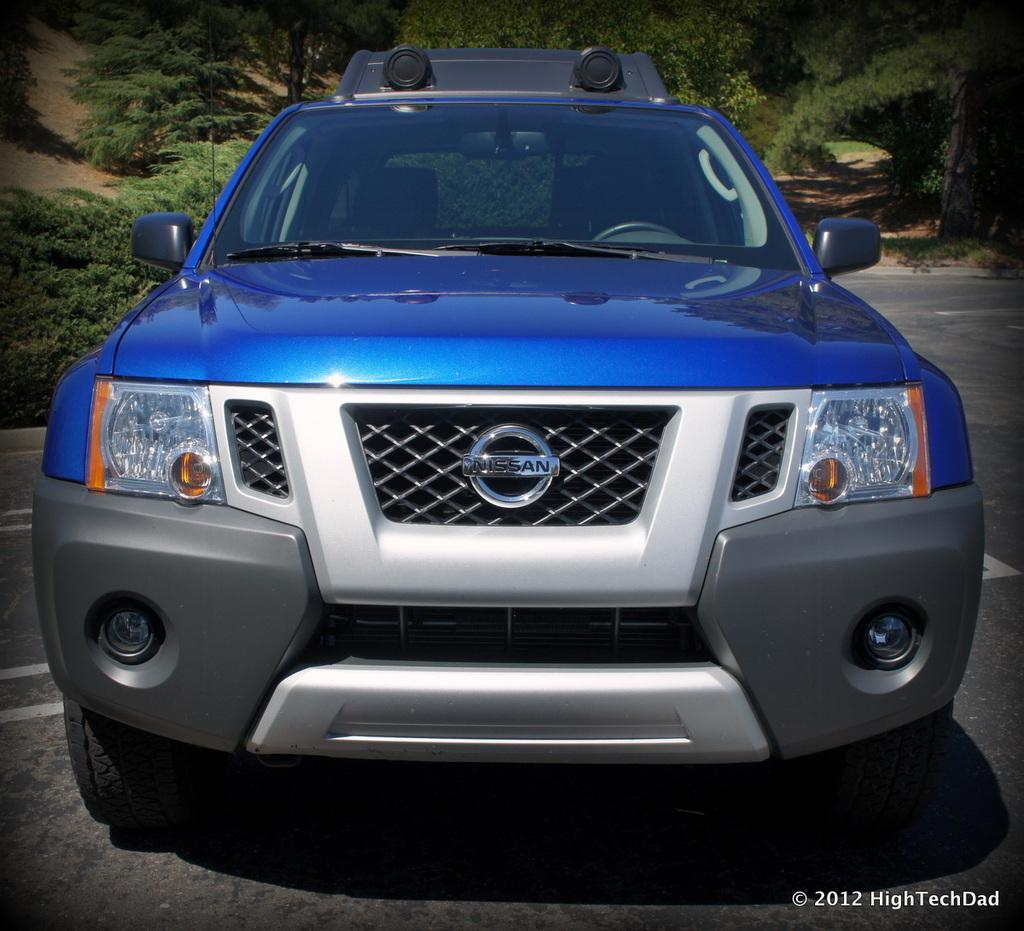What color is the car in the image? The car in the image is blue. Where is the car located in the image? The car is on the road in the image. What can be seen in the background of the image? There are trees in the background of the image. What is visible at the bottom of the image? The road is visible at the bottom of the image. Can you see the coat of the river in the image? There is no river or coat present in the image. 